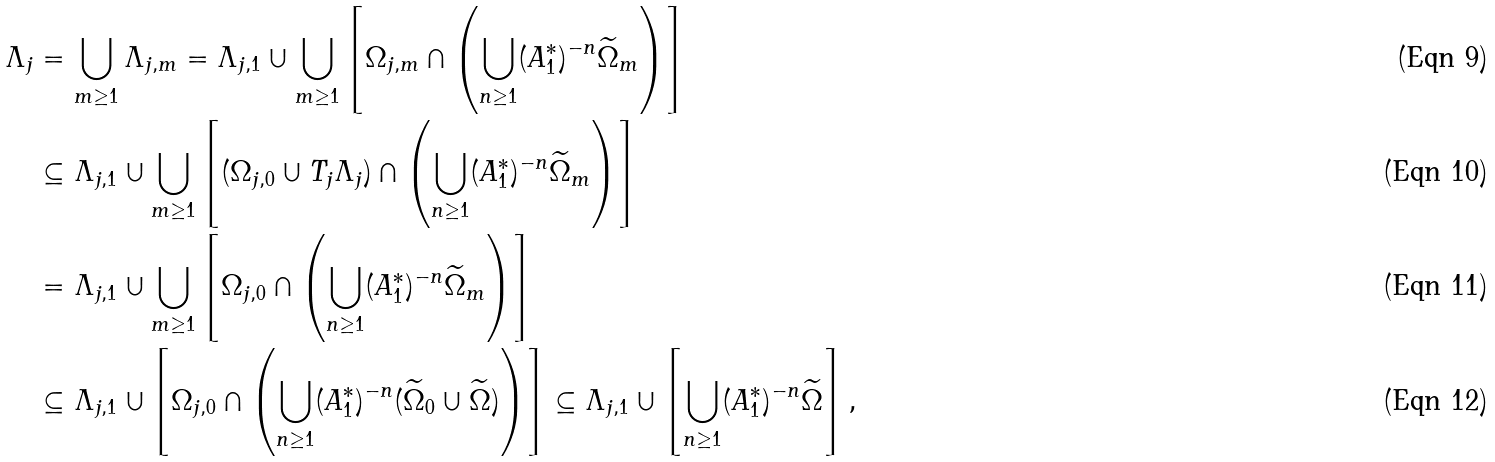<formula> <loc_0><loc_0><loc_500><loc_500>\Lambda _ { j } & = \bigcup _ { m \geq 1 } \Lambda _ { j , m } = \Lambda _ { j , 1 } \cup \bigcup _ { m \geq 1 } \left [ \Omega _ { j , m } \cap \left ( \bigcup _ { n \geq 1 } ( A _ { 1 } ^ { \ast } ) ^ { - n } \widetilde { \Omega } _ { m } \right ) \right ] \\ & \subseteq \Lambda _ { j , 1 } \cup \bigcup _ { m \geq 1 } \left [ ( \Omega _ { j , 0 } \cup T _ { j } \Lambda _ { j } ) \cap \left ( \bigcup _ { n \geq 1 } ( A _ { 1 } ^ { \ast } ) ^ { - n } \widetilde { \Omega } _ { m } \right ) \right ] \\ & = \Lambda _ { j , 1 } \cup \bigcup _ { m \geq 1 } \left [ \Omega _ { j , 0 } \cap \left ( \bigcup _ { n \geq 1 } ( A _ { 1 } ^ { \ast } ) ^ { - n } \widetilde { \Omega } _ { m } \right ) \right ] \\ & \subseteq \Lambda _ { j , 1 } \cup \left [ \Omega _ { j , 0 } \cap \left ( \bigcup _ { n \geq 1 } ( A _ { 1 } ^ { \ast } ) ^ { - n } ( \widetilde { \Omega } _ { 0 } \cup \widetilde { \Omega } ) \right ) \right ] \subseteq \Lambda _ { j , 1 } \cup \left [ \bigcup _ { n \geq 1 } ( A _ { 1 } ^ { \ast } ) ^ { - n } \widetilde { \Omega } \right ] ,</formula> 